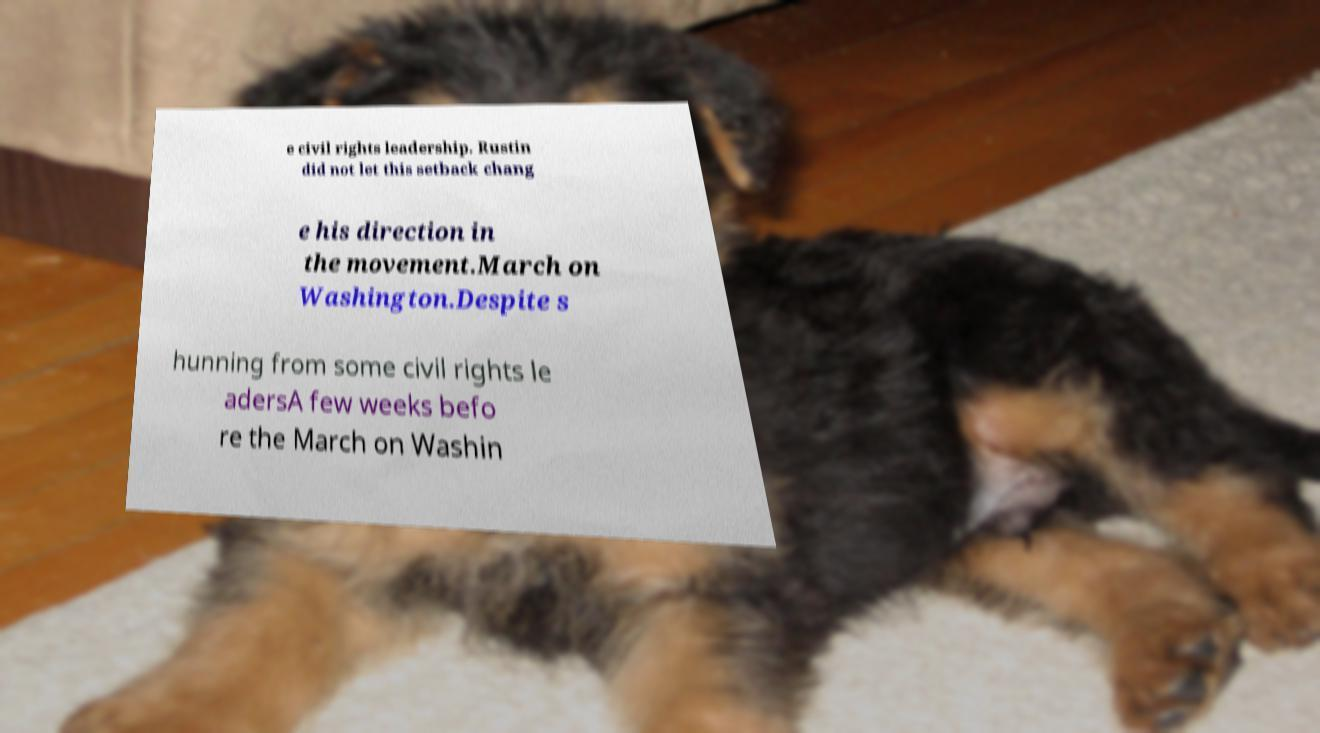Can you accurately transcribe the text from the provided image for me? e civil rights leadership. Rustin did not let this setback chang e his direction in the movement.March on Washington.Despite s hunning from some civil rights le adersA few weeks befo re the March on Washin 